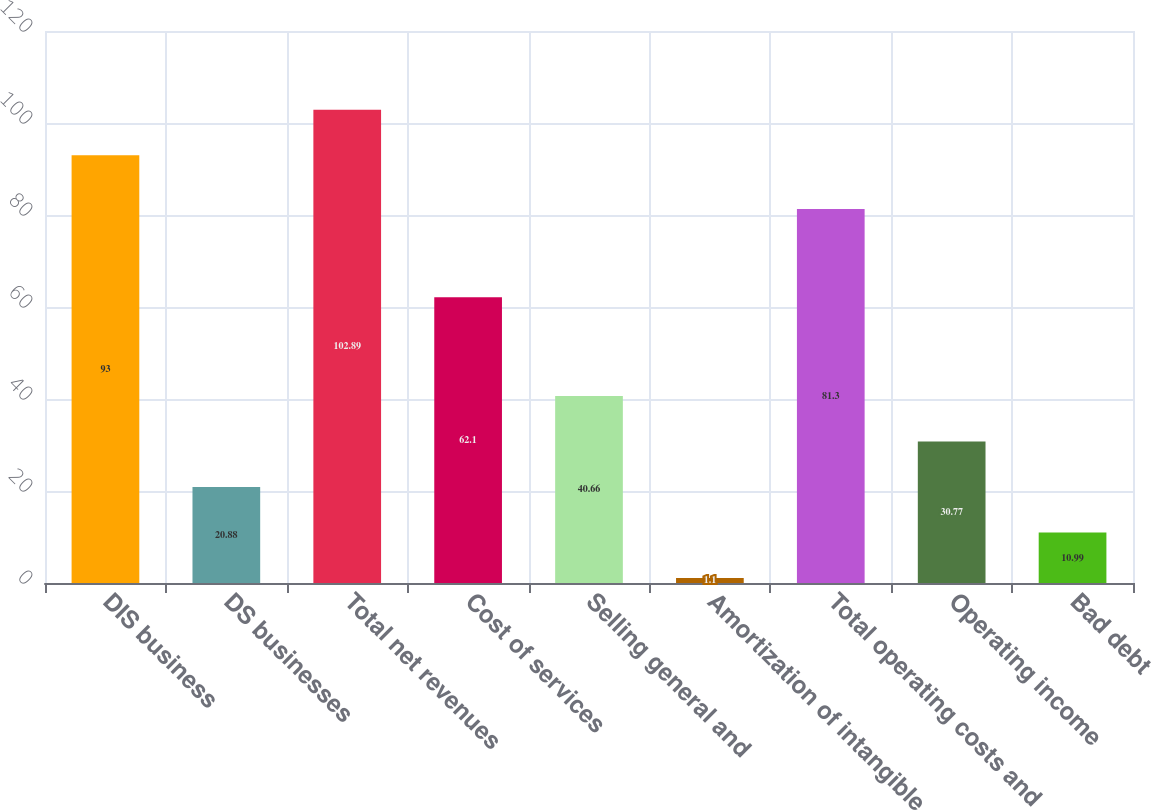<chart> <loc_0><loc_0><loc_500><loc_500><bar_chart><fcel>DIS business<fcel>DS businesses<fcel>Total net revenues<fcel>Cost of services<fcel>Selling general and<fcel>Amortization of intangible<fcel>Total operating costs and<fcel>Operating income<fcel>Bad debt<nl><fcel>93<fcel>20.88<fcel>102.89<fcel>62.1<fcel>40.66<fcel>1.1<fcel>81.3<fcel>30.77<fcel>10.99<nl></chart> 